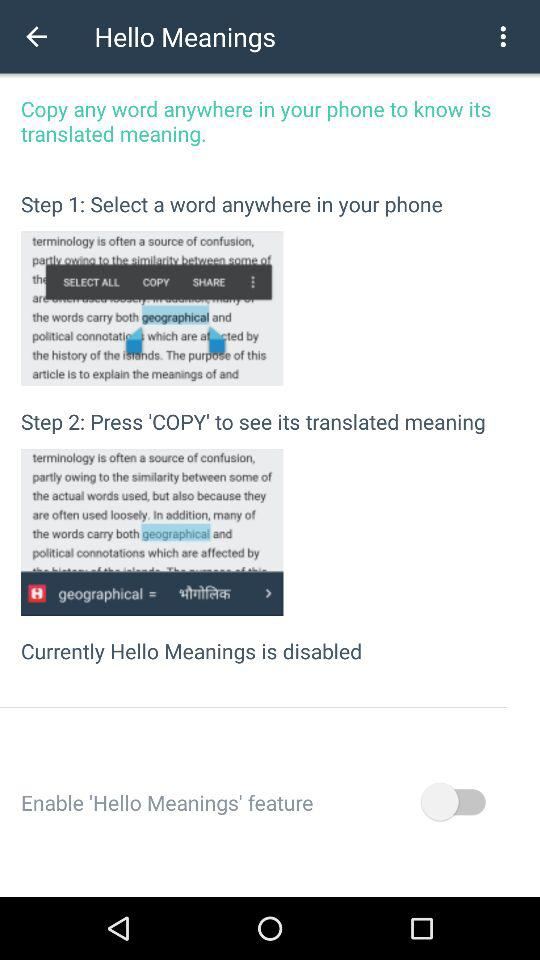What's the status of "Enable 'Hello Meanings' feature"? The status is "off". 